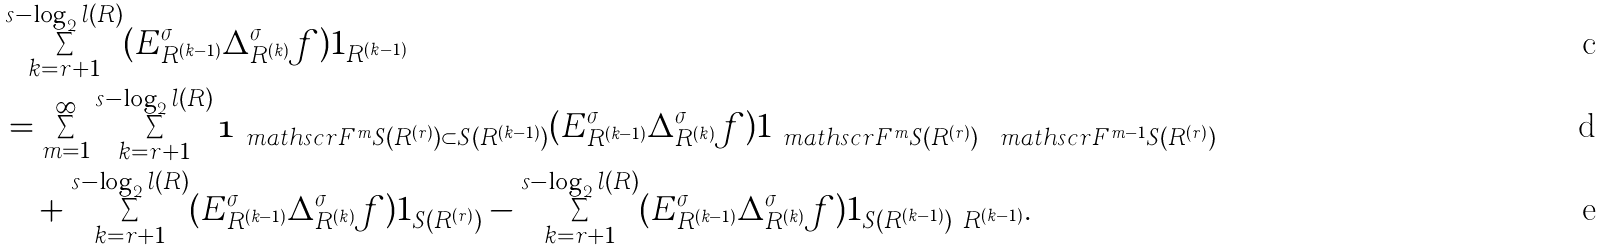Convert formula to latex. <formula><loc_0><loc_0><loc_500><loc_500>& \sum _ { k = r + 1 } ^ { s - \log _ { 2 } l ( R ) } ( E _ { R ^ { ( k - 1 ) } } ^ { \sigma } \Delta _ { R ^ { ( k ) } } ^ { \sigma } f ) 1 _ { R ^ { ( k - 1 ) } } \\ & = \sum _ { m = 1 } ^ { \infty } \sum _ { k = r + 1 } ^ { s - \log _ { 2 } l ( R ) } \mathbf 1 _ { \ m a t h s c r F ^ { m } S ( R ^ { ( r ) } ) \subset S ( R ^ { ( k - 1 ) } ) } ( E ^ { \sigma } _ { R ^ { ( k - 1 ) } } \Delta _ { R ^ { ( k ) } } ^ { \sigma } f ) 1 _ { \ m a t h s c r F ^ { m } S ( R ^ { ( r ) } ) \ \ m a t h s c r F ^ { m - 1 } S ( R ^ { ( r ) } ) } \\ & \quad + \sum _ { k = r + 1 } ^ { s - \log _ { 2 } l ( R ) } ( E _ { R ^ { ( k - 1 ) } } ^ { \sigma } \Delta _ { R ^ { ( k ) } } ^ { \sigma } f ) 1 _ { S ( R ^ { ( r ) } ) } - \sum _ { k = r + 1 } ^ { s - \log _ { 2 } l ( R ) } ( E _ { R ^ { ( k - 1 ) } } ^ { \sigma } \Delta _ { R ^ { ( k ) } } ^ { \sigma } f ) 1 _ { S ( R ^ { ( k - 1 ) } ) \ R ^ { ( k - 1 ) } } .</formula> 